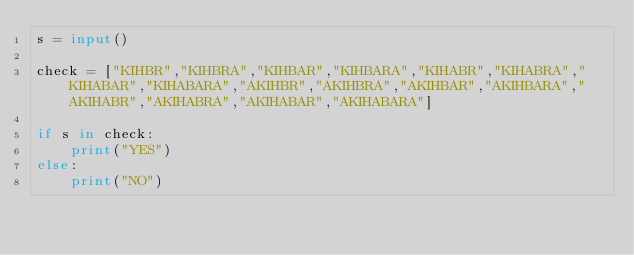<code> <loc_0><loc_0><loc_500><loc_500><_Python_>s = input()

check = ["KIHBR","KIHBRA","KIHBAR","KIHBARA","KIHABR","KIHABRA","KIHABAR","KIHABARA","AKIHBR","AKIHBRA","AKIHBAR","AKIHBARA","AKIHABR","AKIHABRA","AKIHABAR","AKIHABARA"]

if s in check:
    print("YES")
else:
    print("NO")</code> 